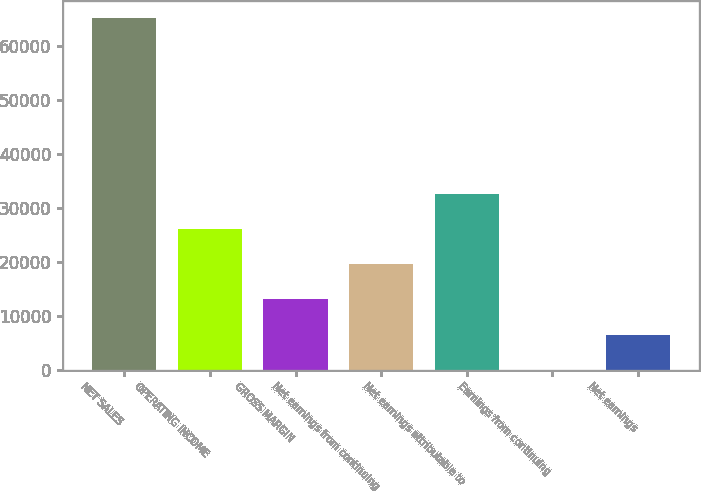<chart> <loc_0><loc_0><loc_500><loc_500><bar_chart><fcel>NET SALES<fcel>OPERATING INCOME<fcel>GROSS MARGIN<fcel>Net earnings from continuing<fcel>Net earnings attributable to<fcel>Earnings from continuing<fcel>Net earnings<nl><fcel>65058<fcel>26025.4<fcel>13014.5<fcel>19520<fcel>32530.8<fcel>3.69<fcel>6509.12<nl></chart> 